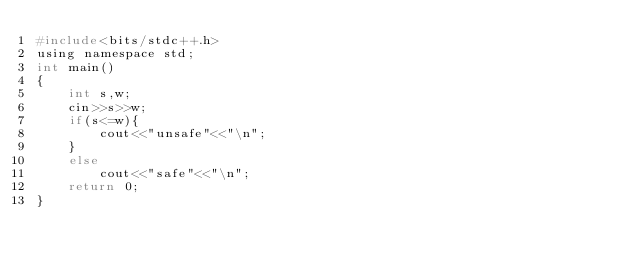Convert code to text. <code><loc_0><loc_0><loc_500><loc_500><_C_>#include<bits/stdc++.h>
using namespace std;
int main()
{
    int s,w;
    cin>>s>>w;
    if(s<=w){
        cout<<"unsafe"<<"\n";
    }
    else
        cout<<"safe"<<"\n";
    return 0;
}</code> 